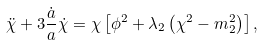Convert formula to latex. <formula><loc_0><loc_0><loc_500><loc_500>\ddot { \chi } + 3 \frac { \dot { a } } { a } \dot { \chi } = \chi \left [ \phi ^ { 2 } + \lambda _ { 2 } \left ( \chi ^ { 2 } - m _ { 2 } ^ { 2 } \right ) \right ] ,</formula> 